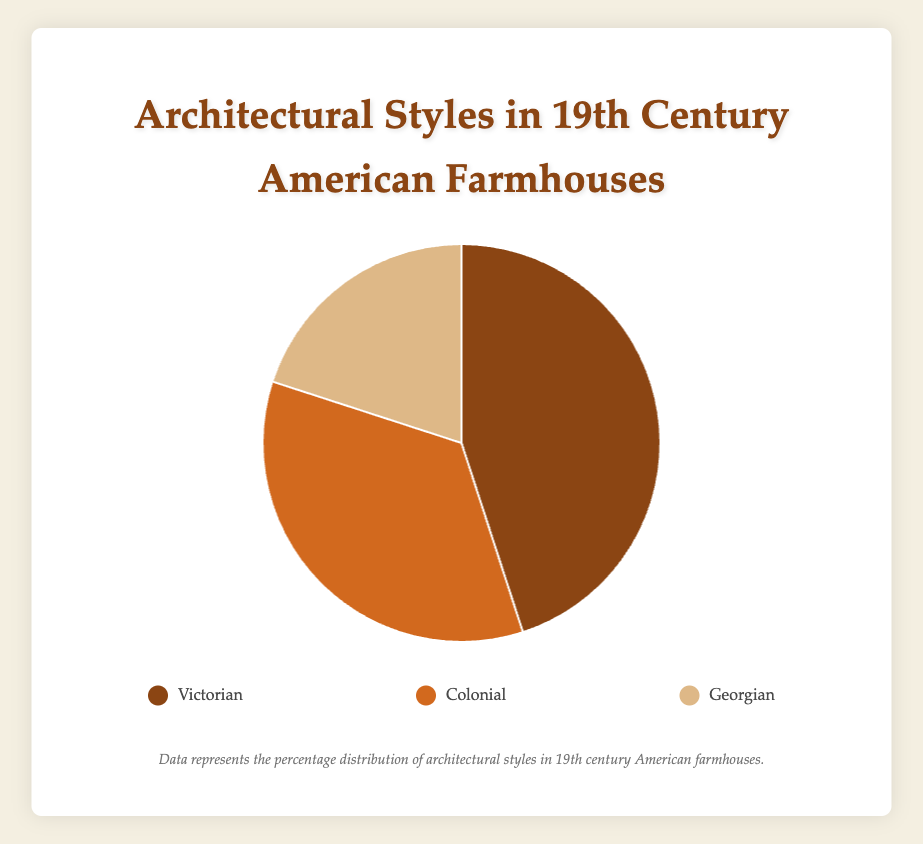What is the most common architectural style among 19th Century American Farmhouses? The data shows Victorian at 45%, Colonial at 35%, and Georgian at 20%. Victorian has the highest percentage, making it the most common style.
Answer: Victorian How much more common is the Victorian style compared to the Georgian style? Victorian is 45% and Georgian is 20%. Subtracting Georgian from Victorian, 45% - 20% = 25%.
Answer: 25% Which architectural style has the smallest representation in 19th Century American Farmhouses? The percentages are Victorian at 45%, Colonial at 35%, and Georgian at 20%. Georgian, with the smallest percentage, is the least represented style.
Answer: Georgian What percentage of 19th Century American Farmhouses are either Victorian or Colonial? Victorian is 45% and Colonial is 35%. Adding these, 45% + 35% = 80%.
Answer: 80% How do the visual colors help identify the different architectural styles in the pie chart? Victorian is represented by a brownish color, Colonial by an orange-brown color, and Georgian by a beige color. This helps quickly distinguish between the styles.
Answer: Differentiating colors (brownish, orange-brown, beige) What is the difference between the percentages of Victorian and Colonial styles? Victorian is 45% and Colonial is 35%. The difference is calculated as 45% - 35% = 10%.
Answer: 10% Which style is more common, Colonial or Georgian, and by how much? Colonial is 35% and Georgian is 20%. Colonial is more common, and the difference is 35% - 20% = 15%.
Answer: Colonial by 15% If you were to combine the percentages of Colonial and Georgian styles, would their total be greater than that of the Victorian style alone? Colonial is 35% and Georgian is 20%. Combined, they are 35% + 20% = 55%. The Victorian style alone is 45%. 55% is greater than 45%.
Answer: Yes Is the percentage of Georgian styles less than half of the percentage of Victorian styles? Victorian is 45%. Half of 45% is 22.5%. Georgian is 20%. Since 20% is less than 22.5%, Georgian is less than half of Victorian.
Answer: Yes What is the total percentage of the farmhouse styles represented in the pie chart? Summing up all percentages: Victorian 45%, Colonial 35%, and Georgian 20%. 45% + 35% + 20% = 100%.
Answer: 100% 